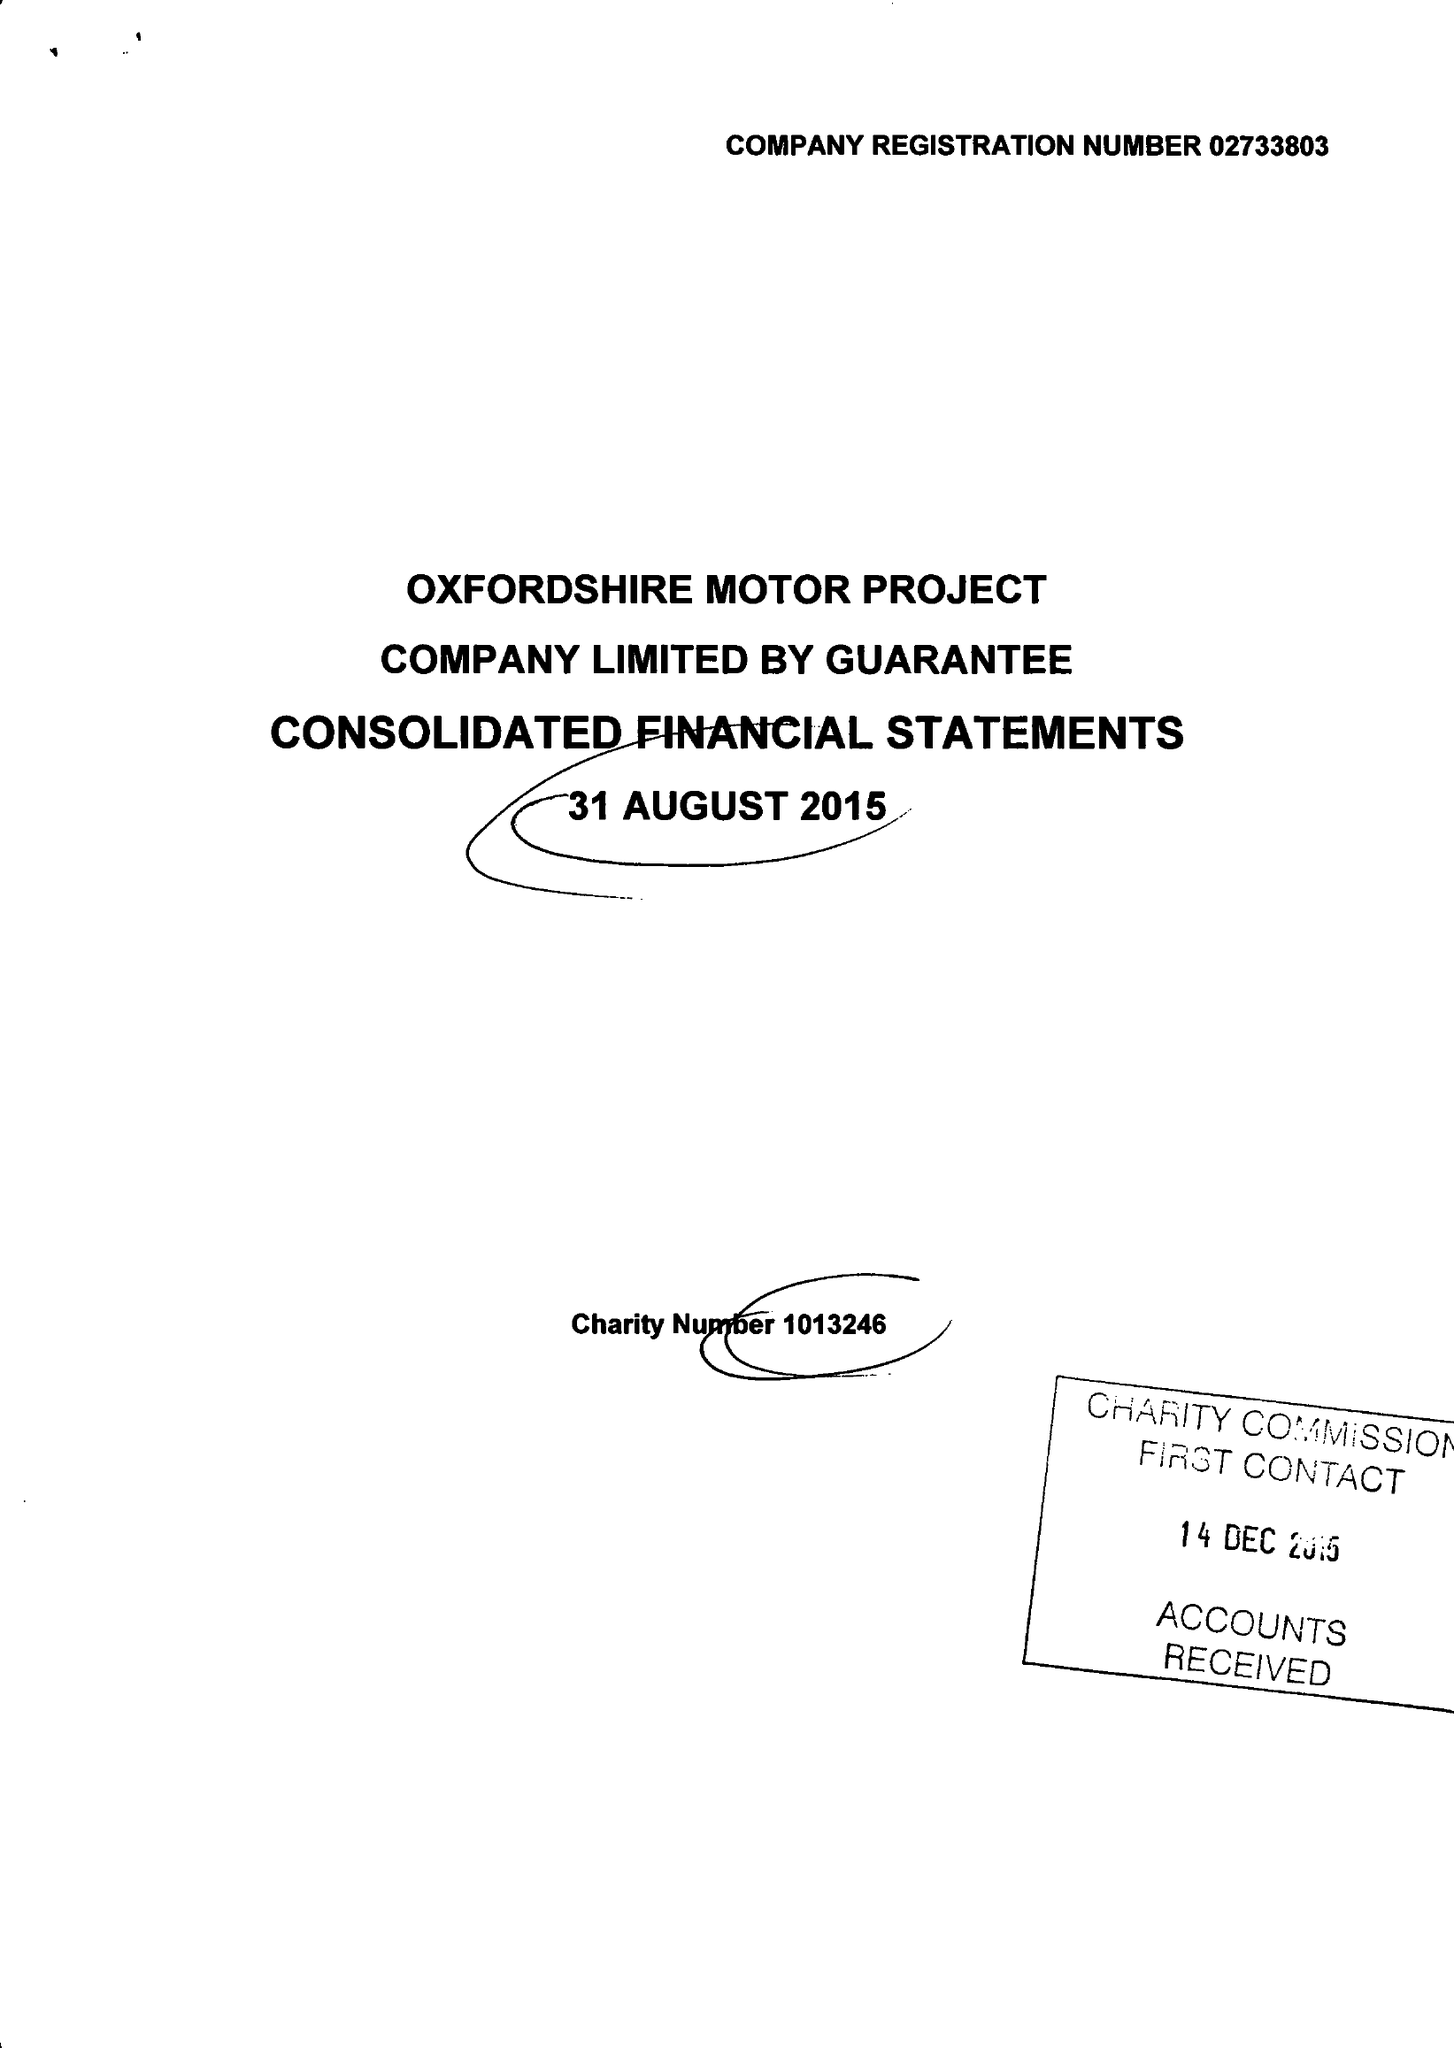What is the value for the income_annually_in_british_pounds?
Answer the question using a single word or phrase. 499559.00 